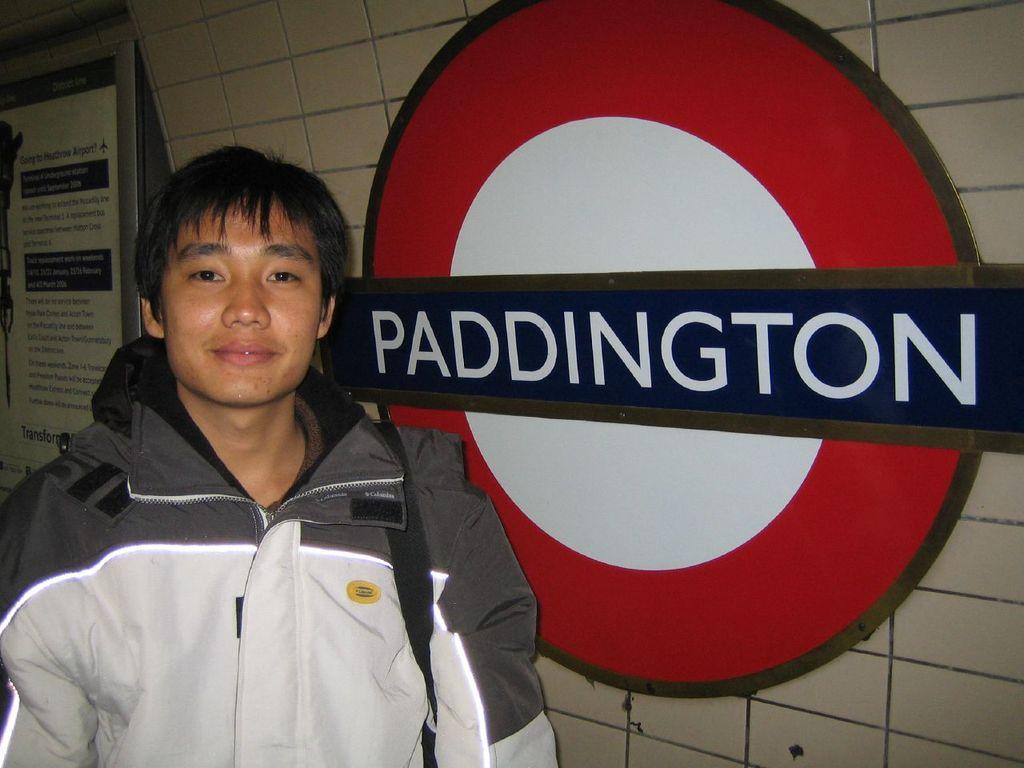<image>
Relay a brief, clear account of the picture shown. A man in a subway next to a sign that says Paddington. 